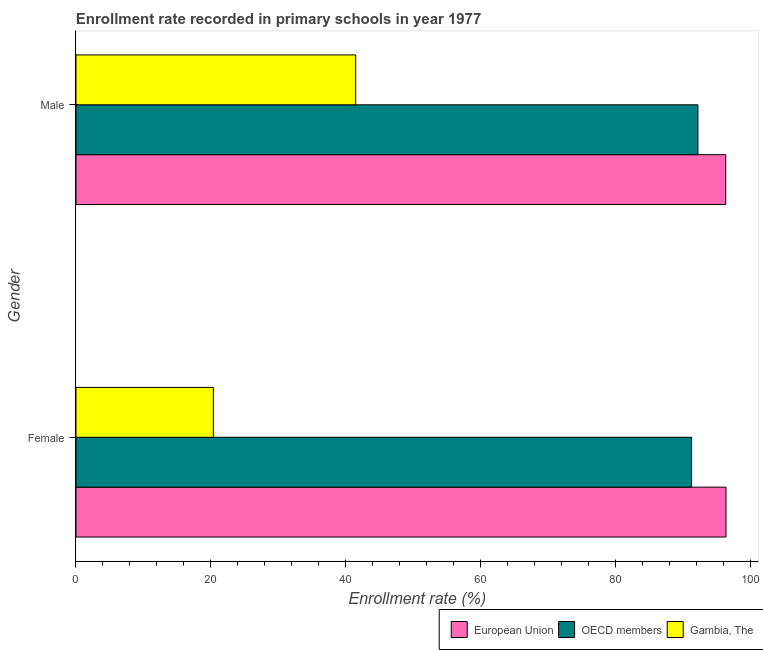How many different coloured bars are there?
Your answer should be compact. 3. How many bars are there on the 2nd tick from the top?
Offer a very short reply. 3. How many bars are there on the 2nd tick from the bottom?
Your answer should be very brief. 3. What is the label of the 2nd group of bars from the top?
Your answer should be very brief. Female. What is the enrollment rate of female students in Gambia, The?
Offer a terse response. 20.36. Across all countries, what is the maximum enrollment rate of male students?
Make the answer very short. 96.3. Across all countries, what is the minimum enrollment rate of male students?
Your answer should be very brief. 41.46. In which country was the enrollment rate of female students minimum?
Offer a terse response. Gambia, The. What is the total enrollment rate of female students in the graph?
Provide a short and direct response. 207.94. What is the difference between the enrollment rate of male students in European Union and that in Gambia, The?
Your answer should be very brief. 54.85. What is the difference between the enrollment rate of female students in European Union and the enrollment rate of male students in OECD members?
Offer a very short reply. 4.16. What is the average enrollment rate of female students per country?
Your answer should be very brief. 69.31. What is the difference between the enrollment rate of male students and enrollment rate of female students in OECD members?
Give a very brief answer. 0.94. What is the ratio of the enrollment rate of male students in European Union to that in Gambia, The?
Your answer should be compact. 2.32. Is the enrollment rate of female students in OECD members less than that in European Union?
Provide a succinct answer. Yes. What does the 1st bar from the bottom in Female represents?
Provide a succinct answer. European Union. How many bars are there?
Provide a short and direct response. 6. Are the values on the major ticks of X-axis written in scientific E-notation?
Your answer should be compact. No. Where does the legend appear in the graph?
Make the answer very short. Bottom right. What is the title of the graph?
Provide a short and direct response. Enrollment rate recorded in primary schools in year 1977. What is the label or title of the X-axis?
Provide a short and direct response. Enrollment rate (%). What is the label or title of the Y-axis?
Make the answer very short. Gender. What is the Enrollment rate (%) of European Union in Female?
Ensure brevity in your answer.  96.34. What is the Enrollment rate (%) of OECD members in Female?
Your answer should be very brief. 91.24. What is the Enrollment rate (%) of Gambia, The in Female?
Your answer should be very brief. 20.36. What is the Enrollment rate (%) in European Union in Male?
Your response must be concise. 96.3. What is the Enrollment rate (%) in OECD members in Male?
Ensure brevity in your answer.  92.18. What is the Enrollment rate (%) in Gambia, The in Male?
Keep it short and to the point. 41.46. Across all Gender, what is the maximum Enrollment rate (%) in European Union?
Ensure brevity in your answer.  96.34. Across all Gender, what is the maximum Enrollment rate (%) in OECD members?
Keep it short and to the point. 92.18. Across all Gender, what is the maximum Enrollment rate (%) in Gambia, The?
Keep it short and to the point. 41.46. Across all Gender, what is the minimum Enrollment rate (%) in European Union?
Make the answer very short. 96.3. Across all Gender, what is the minimum Enrollment rate (%) of OECD members?
Your response must be concise. 91.24. Across all Gender, what is the minimum Enrollment rate (%) in Gambia, The?
Offer a very short reply. 20.36. What is the total Enrollment rate (%) of European Union in the graph?
Ensure brevity in your answer.  192.64. What is the total Enrollment rate (%) in OECD members in the graph?
Provide a short and direct response. 183.42. What is the total Enrollment rate (%) of Gambia, The in the graph?
Your answer should be compact. 61.82. What is the difference between the Enrollment rate (%) of European Union in Female and that in Male?
Give a very brief answer. 0.04. What is the difference between the Enrollment rate (%) of OECD members in Female and that in Male?
Your answer should be compact. -0.94. What is the difference between the Enrollment rate (%) in Gambia, The in Female and that in Male?
Make the answer very short. -21.1. What is the difference between the Enrollment rate (%) of European Union in Female and the Enrollment rate (%) of OECD members in Male?
Your answer should be compact. 4.16. What is the difference between the Enrollment rate (%) in European Union in Female and the Enrollment rate (%) in Gambia, The in Male?
Your answer should be compact. 54.88. What is the difference between the Enrollment rate (%) in OECD members in Female and the Enrollment rate (%) in Gambia, The in Male?
Provide a short and direct response. 49.78. What is the average Enrollment rate (%) in European Union per Gender?
Give a very brief answer. 96.32. What is the average Enrollment rate (%) in OECD members per Gender?
Make the answer very short. 91.71. What is the average Enrollment rate (%) in Gambia, The per Gender?
Provide a succinct answer. 30.91. What is the difference between the Enrollment rate (%) of European Union and Enrollment rate (%) of OECD members in Female?
Offer a terse response. 5.1. What is the difference between the Enrollment rate (%) of European Union and Enrollment rate (%) of Gambia, The in Female?
Your answer should be compact. 75.98. What is the difference between the Enrollment rate (%) in OECD members and Enrollment rate (%) in Gambia, The in Female?
Ensure brevity in your answer.  70.88. What is the difference between the Enrollment rate (%) of European Union and Enrollment rate (%) of OECD members in Male?
Your answer should be very brief. 4.12. What is the difference between the Enrollment rate (%) in European Union and Enrollment rate (%) in Gambia, The in Male?
Your answer should be very brief. 54.85. What is the difference between the Enrollment rate (%) of OECD members and Enrollment rate (%) of Gambia, The in Male?
Ensure brevity in your answer.  50.73. What is the ratio of the Enrollment rate (%) in European Union in Female to that in Male?
Give a very brief answer. 1. What is the ratio of the Enrollment rate (%) in OECD members in Female to that in Male?
Your response must be concise. 0.99. What is the ratio of the Enrollment rate (%) of Gambia, The in Female to that in Male?
Your answer should be very brief. 0.49. What is the difference between the highest and the second highest Enrollment rate (%) of European Union?
Offer a terse response. 0.04. What is the difference between the highest and the second highest Enrollment rate (%) of OECD members?
Your answer should be compact. 0.94. What is the difference between the highest and the second highest Enrollment rate (%) of Gambia, The?
Give a very brief answer. 21.1. What is the difference between the highest and the lowest Enrollment rate (%) in European Union?
Offer a terse response. 0.04. What is the difference between the highest and the lowest Enrollment rate (%) in OECD members?
Ensure brevity in your answer.  0.94. What is the difference between the highest and the lowest Enrollment rate (%) of Gambia, The?
Offer a terse response. 21.1. 